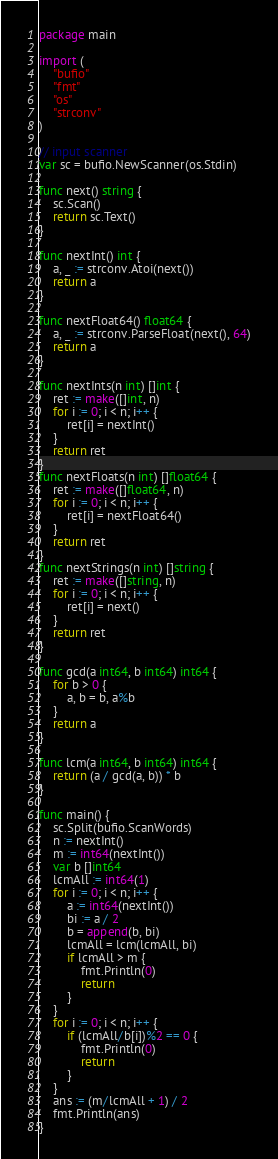Convert code to text. <code><loc_0><loc_0><loc_500><loc_500><_Go_>package main

import (
	"bufio"
	"fmt"
	"os"
	"strconv"
)

// input scanner
var sc = bufio.NewScanner(os.Stdin)

func next() string {
	sc.Scan()
	return sc.Text()
}

func nextInt() int {
	a, _ := strconv.Atoi(next())
	return a
}

func nextFloat64() float64 {
	a, _ := strconv.ParseFloat(next(), 64)
	return a
}

func nextInts(n int) []int {
	ret := make([]int, n)
	for i := 0; i < n; i++ {
		ret[i] = nextInt()
	}
	return ret
}
func nextFloats(n int) []float64 {
	ret := make([]float64, n)
	for i := 0; i < n; i++ {
		ret[i] = nextFloat64()
	}
	return ret
}
func nextStrings(n int) []string {
	ret := make([]string, n)
	for i := 0; i < n; i++ {
		ret[i] = next()
	}
	return ret
}

func gcd(a int64, b int64) int64 {
	for b > 0 {
		a, b = b, a%b
	}
	return a
}

func lcm(a int64, b int64) int64 {
	return (a / gcd(a, b)) * b
}

func main() {
	sc.Split(bufio.ScanWords)
	n := nextInt()
	m := int64(nextInt())
	var b []int64
	lcmAll := int64(1)
	for i := 0; i < n; i++ {
		a := int64(nextInt())
		bi := a / 2
		b = append(b, bi)
		lcmAll = lcm(lcmAll, bi)
		if lcmAll > m {
			fmt.Println(0)
			return
		}
	}
	for i := 0; i < n; i++ {
		if (lcmAll/b[i])%2 == 0 {
			fmt.Println(0)
			return
		}
	}
	ans := (m/lcmAll + 1) / 2
	fmt.Println(ans)
}
</code> 